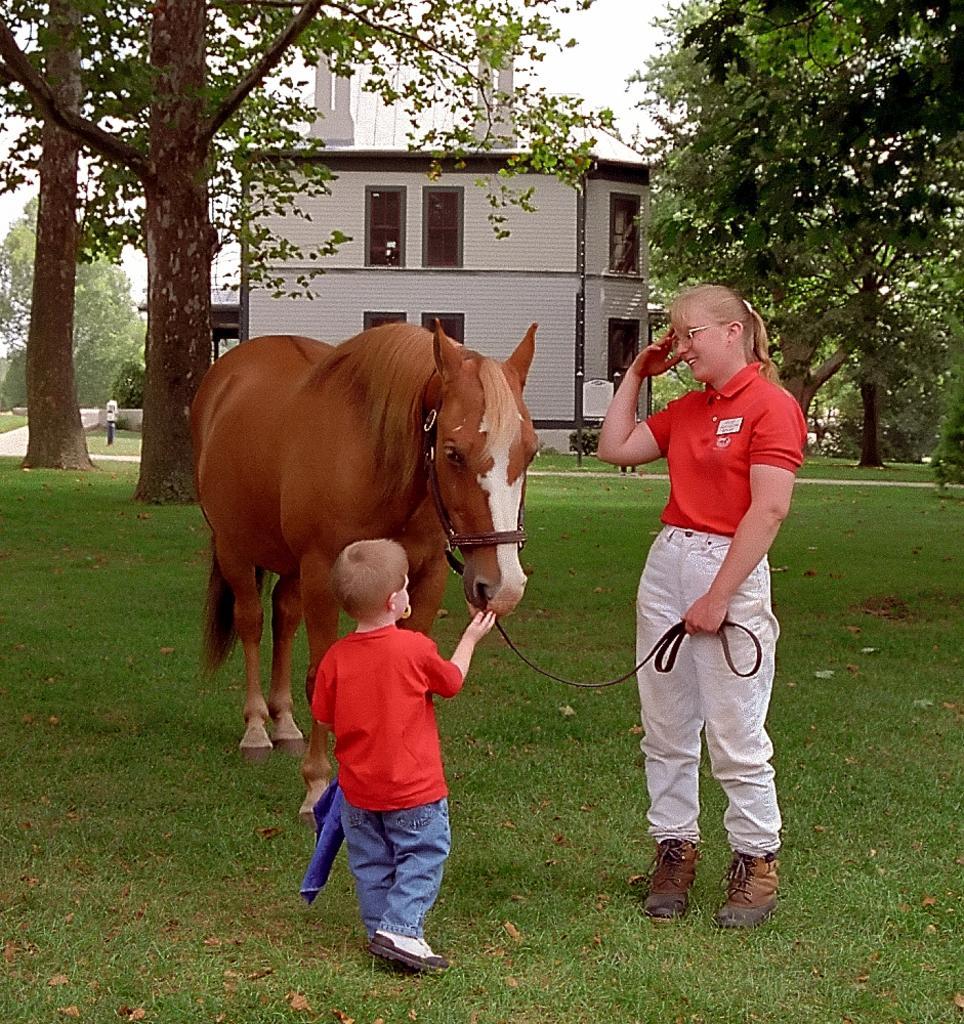Can you describe this image briefly? This is the picture where we have a lady and a little boy holding the horse which is on the grass and behind them there are some trees and a house. 